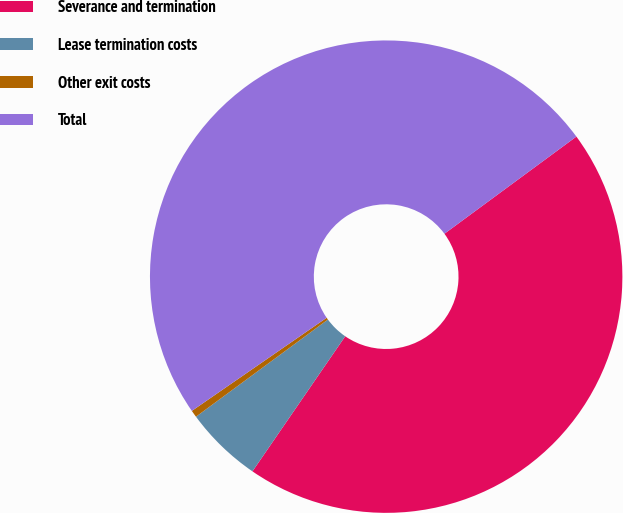<chart> <loc_0><loc_0><loc_500><loc_500><pie_chart><fcel>Severance and termination<fcel>Lease termination costs<fcel>Other exit costs<fcel>Total<nl><fcel>44.68%<fcel>5.32%<fcel>0.48%<fcel>49.52%<nl></chart> 